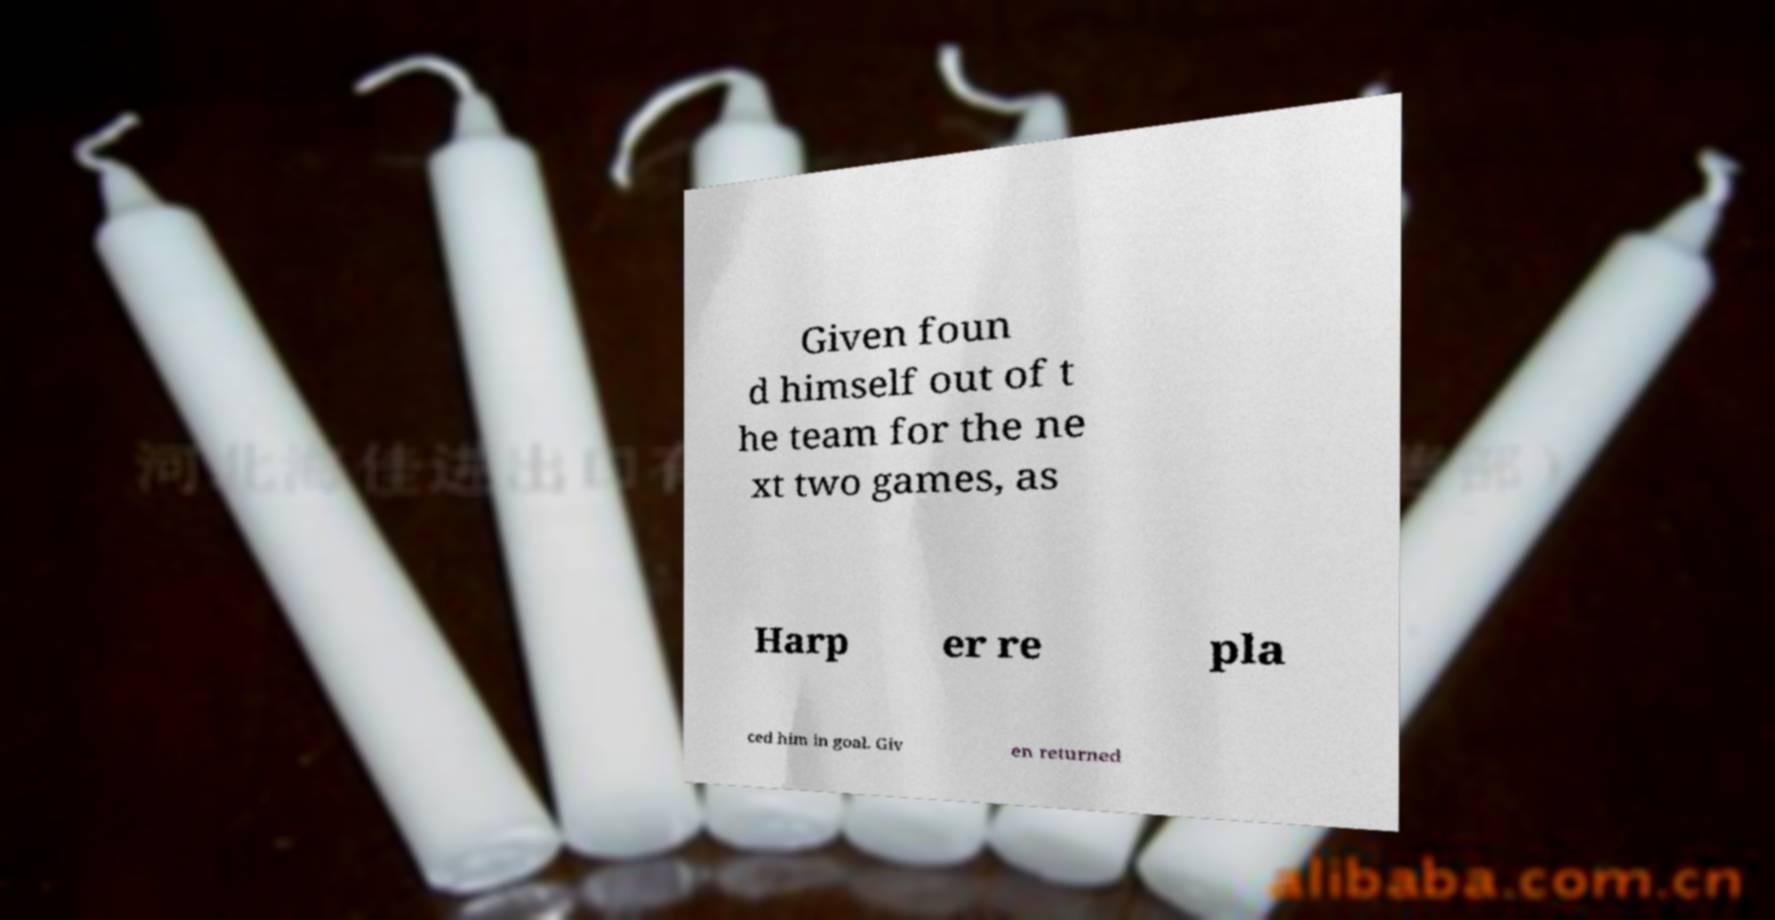Could you assist in decoding the text presented in this image and type it out clearly? Given foun d himself out of t he team for the ne xt two games, as Harp er re pla ced him in goal. Giv en returned 